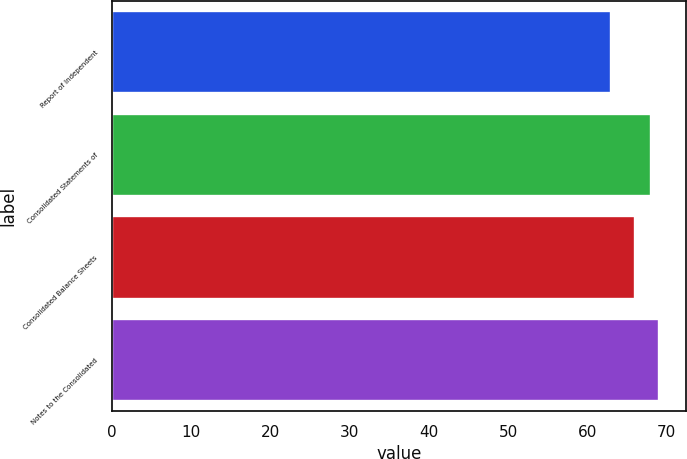<chart> <loc_0><loc_0><loc_500><loc_500><bar_chart><fcel>Report of Independent<fcel>Consolidated Statements of<fcel>Consolidated Balance Sheets<fcel>Notes to the Consolidated<nl><fcel>63<fcel>68<fcel>66<fcel>69<nl></chart> 